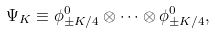Convert formula to latex. <formula><loc_0><loc_0><loc_500><loc_500>\Psi _ { K } \equiv \phi _ { \pm K / 4 } ^ { 0 } \otimes \cdots \otimes \phi _ { \pm K / 4 } ^ { 0 } ,</formula> 